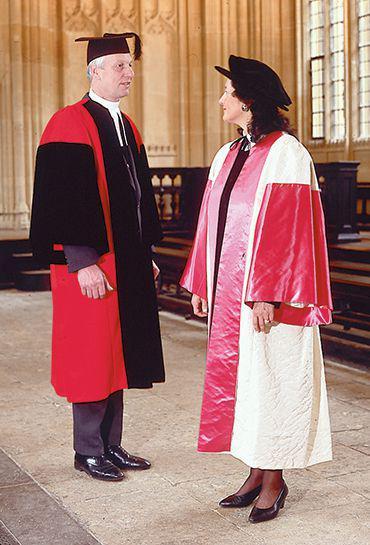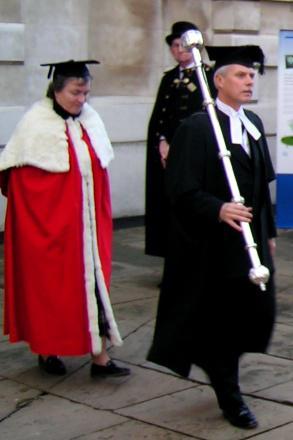The first image is the image on the left, the second image is the image on the right. Given the left and right images, does the statement "An image does not show exactly two people dressed for an occasion." hold true? Answer yes or no. Yes. 